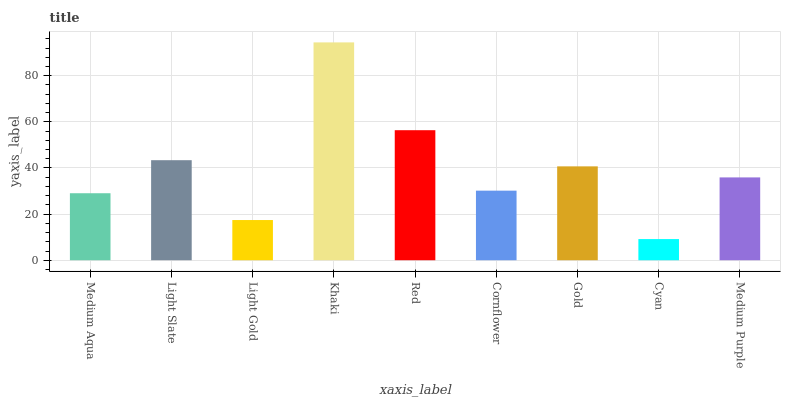Is Cyan the minimum?
Answer yes or no. Yes. Is Khaki the maximum?
Answer yes or no. Yes. Is Light Slate the minimum?
Answer yes or no. No. Is Light Slate the maximum?
Answer yes or no. No. Is Light Slate greater than Medium Aqua?
Answer yes or no. Yes. Is Medium Aqua less than Light Slate?
Answer yes or no. Yes. Is Medium Aqua greater than Light Slate?
Answer yes or no. No. Is Light Slate less than Medium Aqua?
Answer yes or no. No. Is Medium Purple the high median?
Answer yes or no. Yes. Is Medium Purple the low median?
Answer yes or no. Yes. Is Red the high median?
Answer yes or no. No. Is Light Slate the low median?
Answer yes or no. No. 